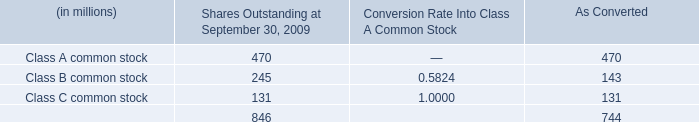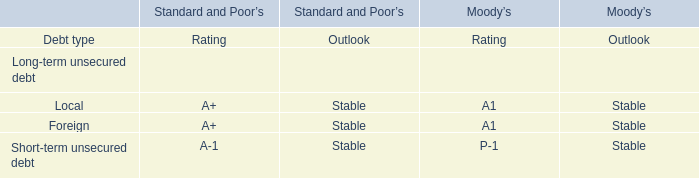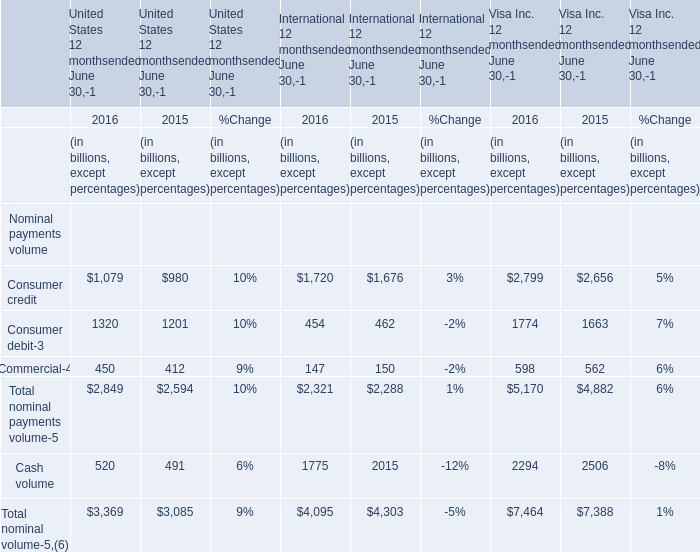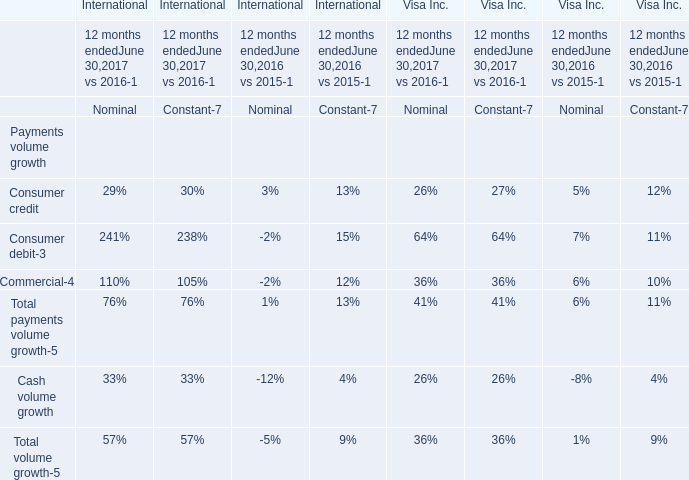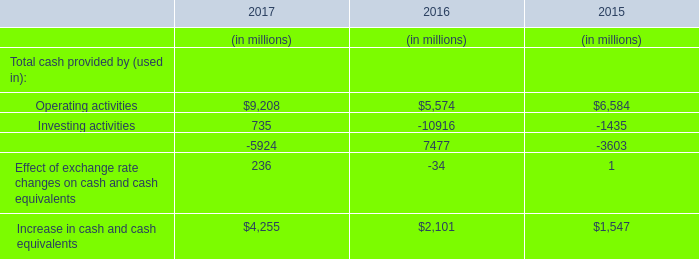What do all International 12 monthsended June 30 sum up, excluding those negative ones in 2016? (in billion) 
Computations: (2321 + 1775)
Answer: 4096.0. 